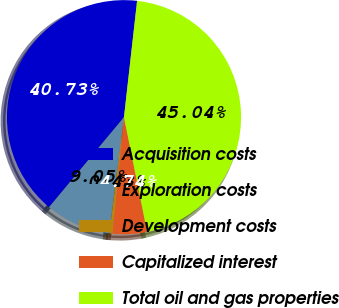<chart> <loc_0><loc_0><loc_500><loc_500><pie_chart><fcel>Acquisition costs<fcel>Exploration costs<fcel>Development costs<fcel>Capitalized interest<fcel>Total oil and gas properties<nl><fcel>40.73%<fcel>9.05%<fcel>0.43%<fcel>4.74%<fcel>45.04%<nl></chart> 